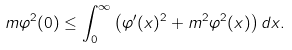Convert formula to latex. <formula><loc_0><loc_0><loc_500><loc_500>m \varphi ^ { 2 } ( 0 ) \leq \int _ { 0 } ^ { \infty } \left ( \varphi ^ { \prime } ( x ) ^ { 2 } + m ^ { 2 } \varphi ^ { 2 } ( x ) \right ) d x .</formula> 